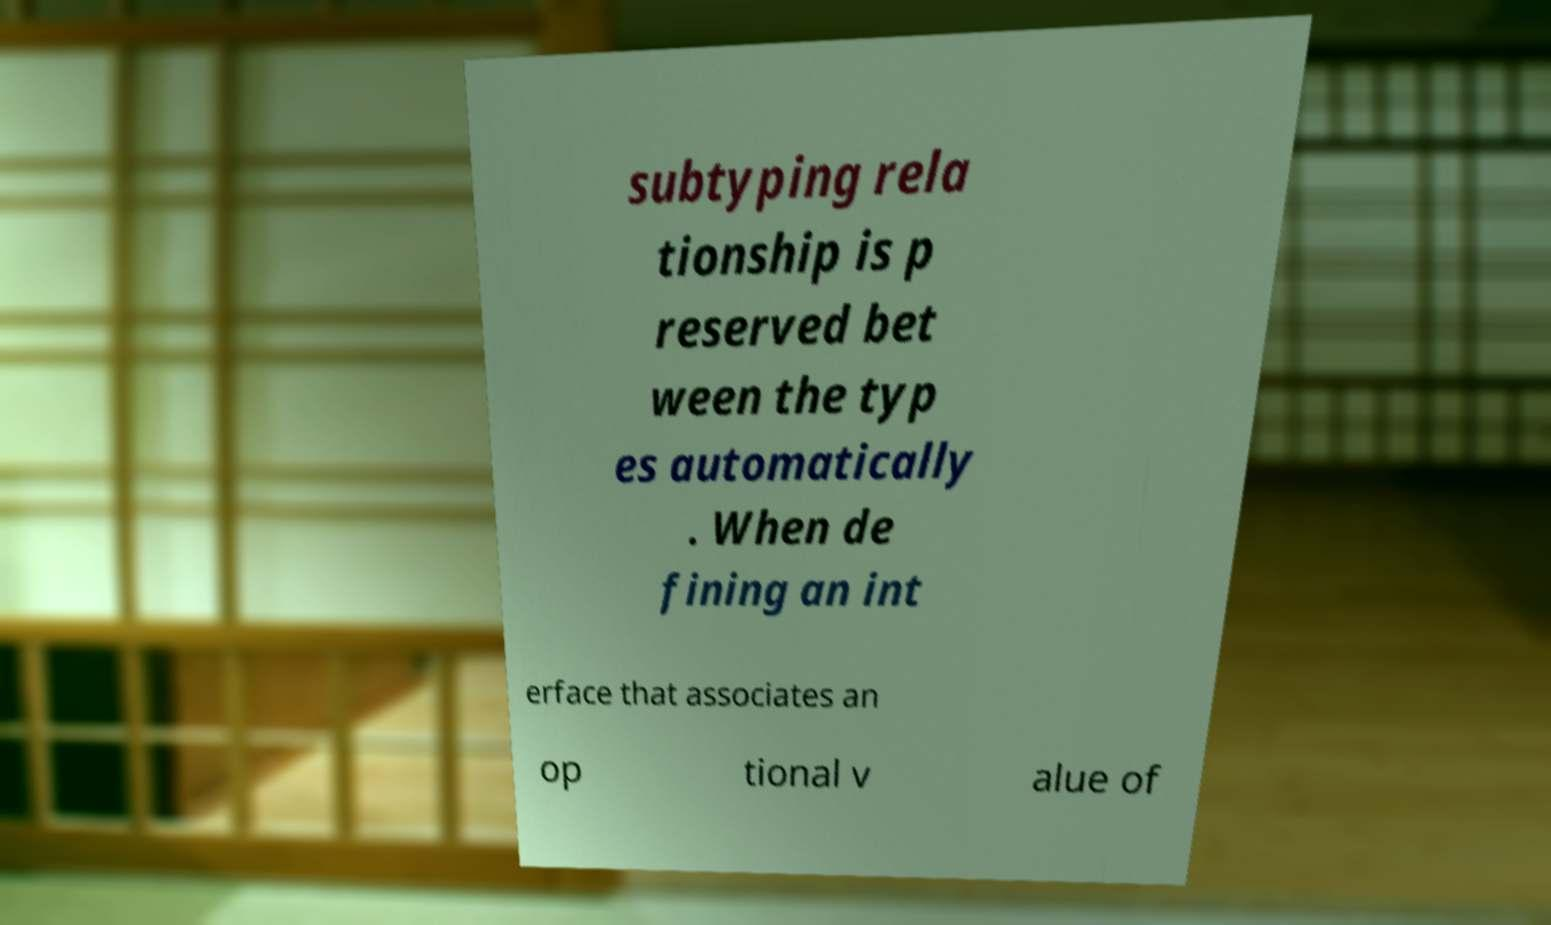Could you assist in decoding the text presented in this image and type it out clearly? subtyping rela tionship is p reserved bet ween the typ es automatically . When de fining an int erface that associates an op tional v alue of 